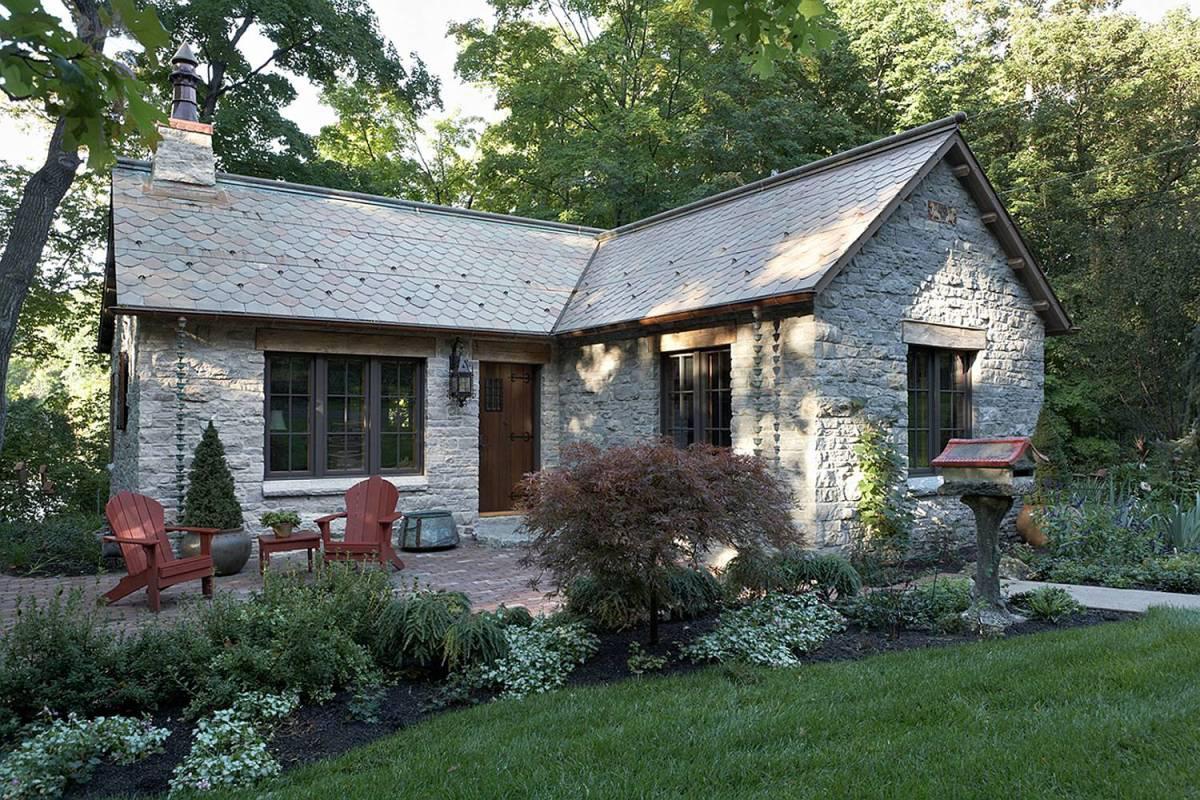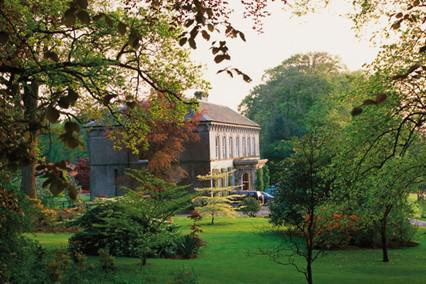The first image is the image on the left, the second image is the image on the right. Examine the images to the left and right. Is the description "An image shows a white house with a grayish-brown roof that curves around and over a window." accurate? Answer yes or no. No. 